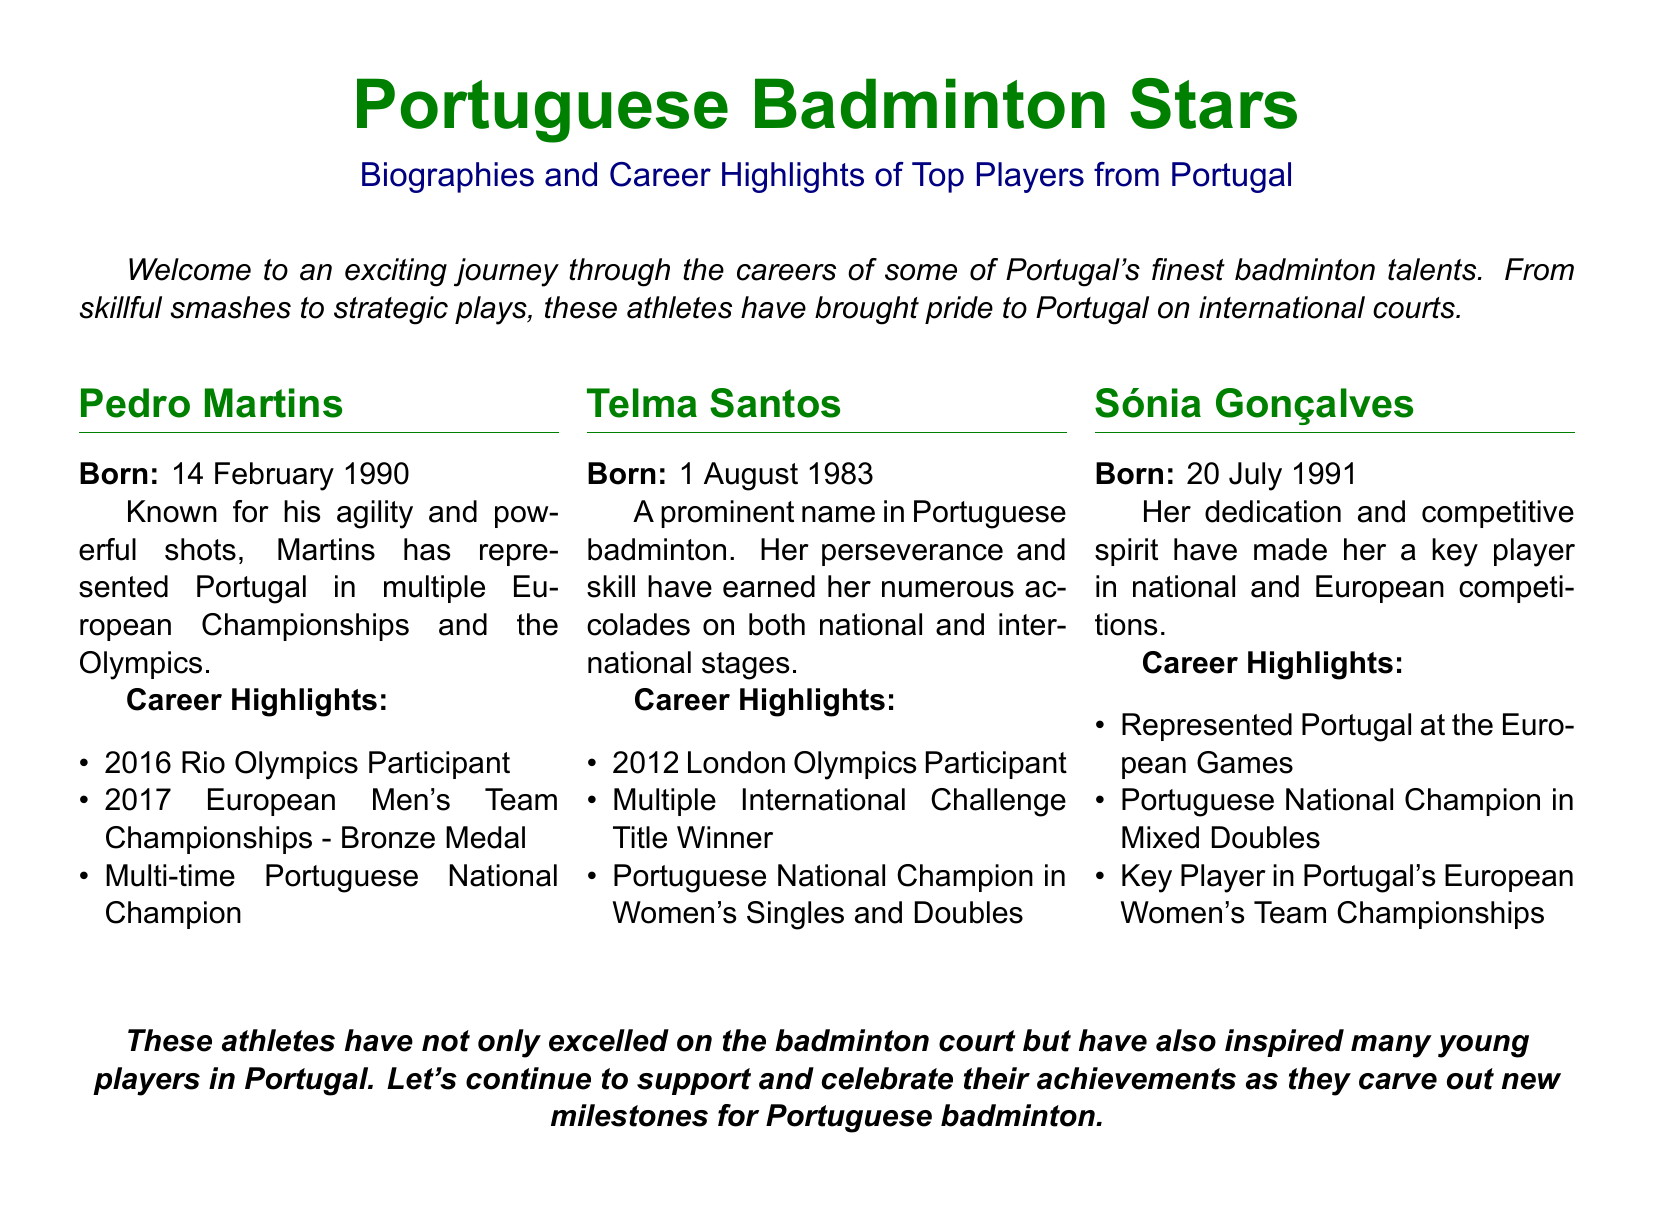What is Pedro Martins' date of birth? Pedro Martins is listed as being born on the 14th of February, 1990.
Answer: 14 February 1990 Which Olympic event did Telma Santos compete in? The document states that Telma Santos participated in the 2012 London Olympics.
Answer: 2012 London Olympics How many times is Pedro Martins a National Champion? The document mentions that Pedro Martins is a multi-time Portuguese National Champion, indicating he has won on multiple occasions.
Answer: Multi-time What national title did Sónia Gonçalves win? Sónia Gonçalves is noted as the Portuguese National Champion in Mixed Doubles.
Answer: Mixed Doubles What medal did Pedro Martins win at the 2017 European Championships? According to the document, Pedro Martins won a bronze medal at the 2017 European Men's Team Championships.
Answer: Bronze Medal What is a common thread among all three players highlighted? All three players are recognized for their achievements in badminton and have represented Portugal internationally.
Answer: International Representation Which player was born first? Telma Santos was born on 1 August 1983, making her the oldest among the three players listed.
Answer: Telma Santos What type of document is this? The document provides biographies and highlights of badminton players, specifically focusing on Portuguese talents.
Answer: Playbill How has Telma Santos impacted badminton in Portugal? It is stated that her perseverance and skill have earned her numerous accolades, indicating she has had a significant impact.
Answer: Significant Impact 